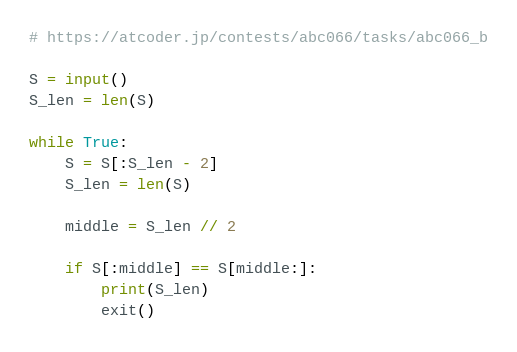<code> <loc_0><loc_0><loc_500><loc_500><_Python_># https://atcoder.jp/contests/abc066/tasks/abc066_b

S = input()
S_len = len(S)

while True:
    S = S[:S_len - 2]
    S_len = len(S)

    middle = S_len // 2

    if S[:middle] == S[middle:]:
        print(S_len)
        exit()</code> 